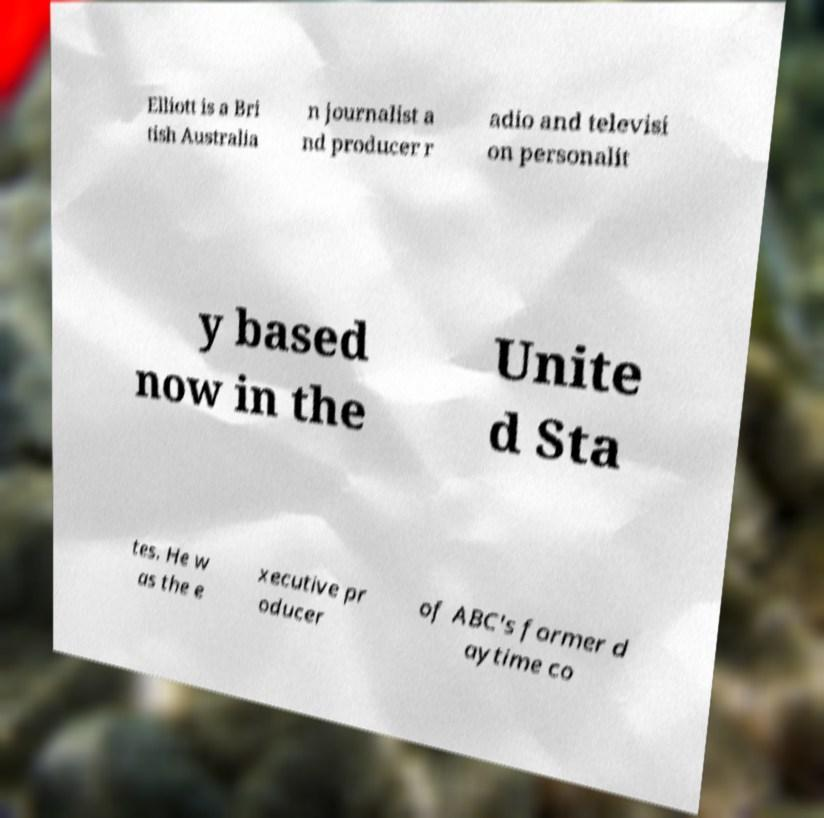What messages or text are displayed in this image? I need them in a readable, typed format. Elliott is a Bri tish Australia n journalist a nd producer r adio and televisi on personalit y based now in the Unite d Sta tes. He w as the e xecutive pr oducer of ABC's former d aytime co 